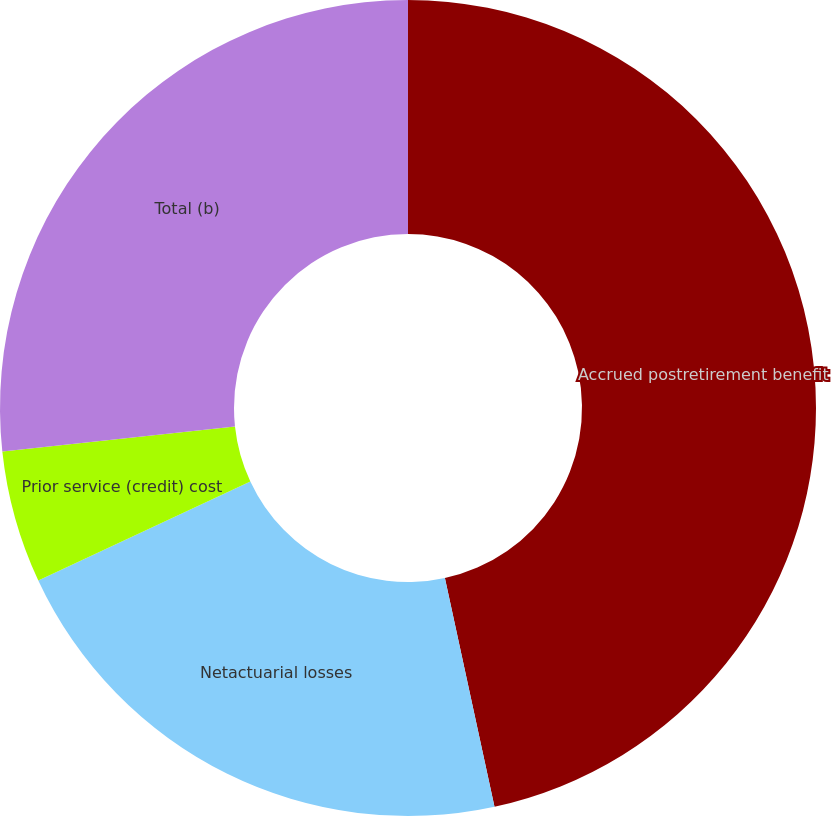<chart> <loc_0><loc_0><loc_500><loc_500><pie_chart><fcel>Accrued postretirement benefit<fcel>Netactuarial losses<fcel>Prior service (credit) cost<fcel>Total (b)<nl><fcel>46.6%<fcel>21.45%<fcel>5.25%<fcel>26.7%<nl></chart> 